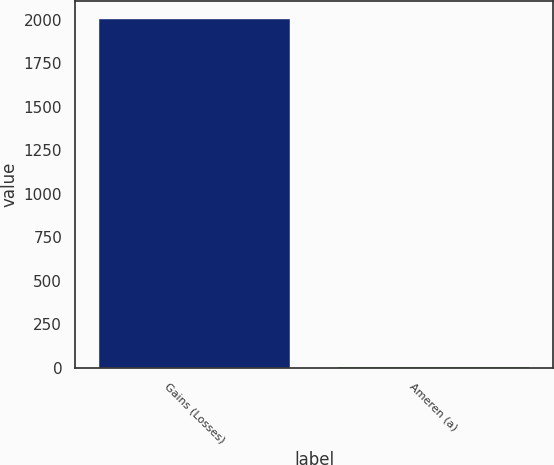<chart> <loc_0><loc_0><loc_500><loc_500><bar_chart><fcel>Gains (Losses)<fcel>Ameren (a)<nl><fcel>2007<fcel>6<nl></chart> 